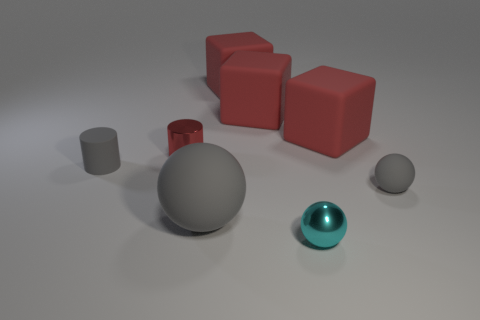What number of blocks are the same color as the metallic cylinder?
Provide a succinct answer. 3. There is a red thing on the right side of the metallic sphere; does it have the same size as the small gray matte sphere?
Provide a succinct answer. No. There is a cylinder left of the tiny red object; is its color the same as the large sphere?
Your answer should be compact. Yes. Is the material of the cyan object the same as the tiny gray sphere?
Provide a short and direct response. No. There is a thing that is both on the left side of the tiny cyan metal thing and in front of the small matte ball; what is its material?
Ensure brevity in your answer.  Rubber. What is the size of the gray matte object that is the same shape as the red shiny object?
Offer a terse response. Small. The gray object behind the tiny gray rubber ball has what shape?
Offer a terse response. Cylinder. Is the material of the gray ball that is to the right of the big gray rubber sphere the same as the large thing in front of the small gray matte cylinder?
Keep it short and to the point. Yes. What shape is the cyan thing?
Give a very brief answer. Sphere. Is the number of large matte balls that are in front of the metallic ball the same as the number of purple blocks?
Provide a succinct answer. Yes. 